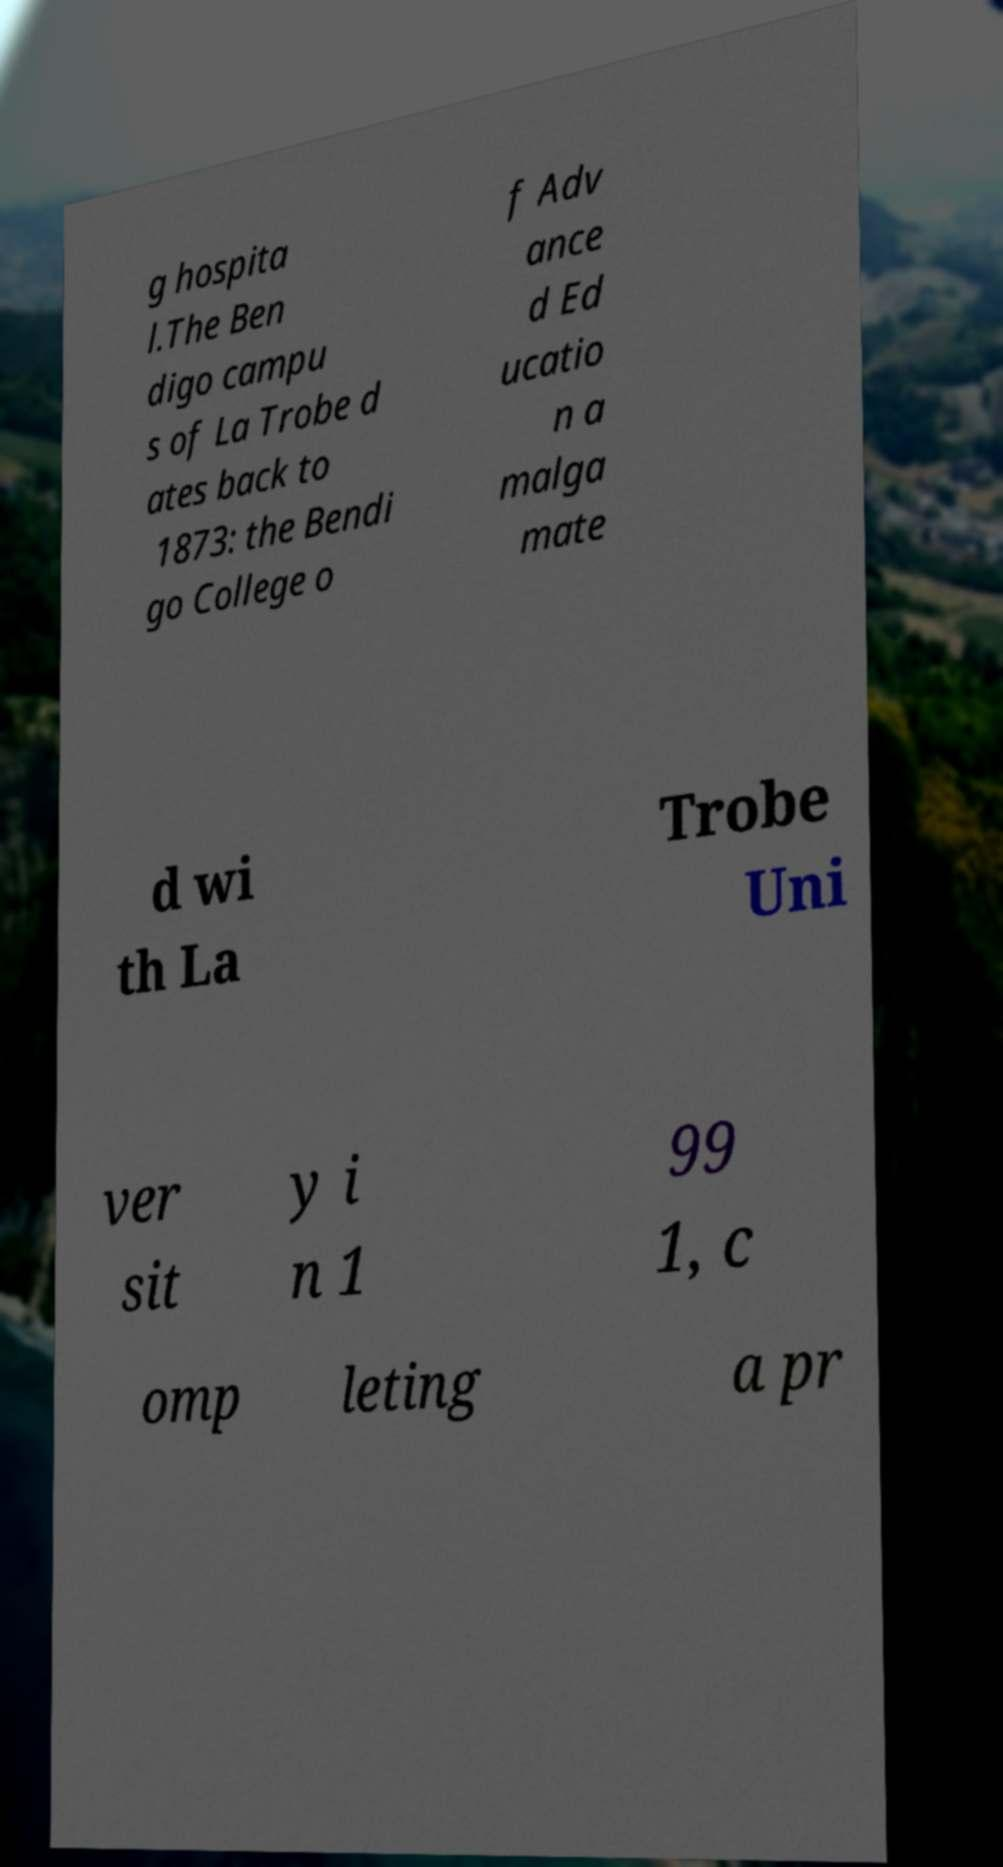There's text embedded in this image that I need extracted. Can you transcribe it verbatim? g hospita l.The Ben digo campu s of La Trobe d ates back to 1873: the Bendi go College o f Adv ance d Ed ucatio n a malga mate d wi th La Trobe Uni ver sit y i n 1 99 1, c omp leting a pr 